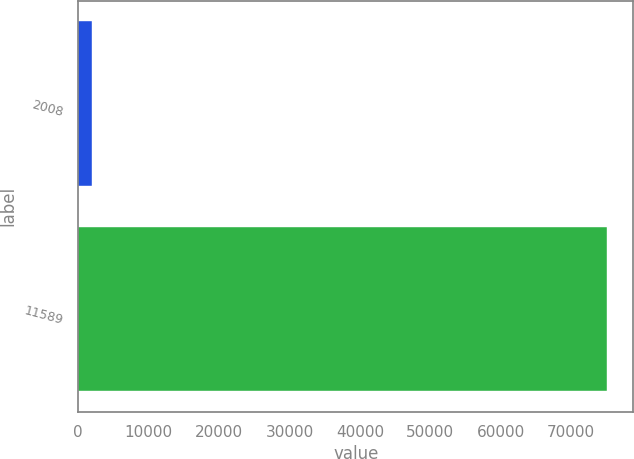<chart> <loc_0><loc_0><loc_500><loc_500><bar_chart><fcel>2008<fcel>11589<nl><fcel>2006<fcel>75048<nl></chart> 